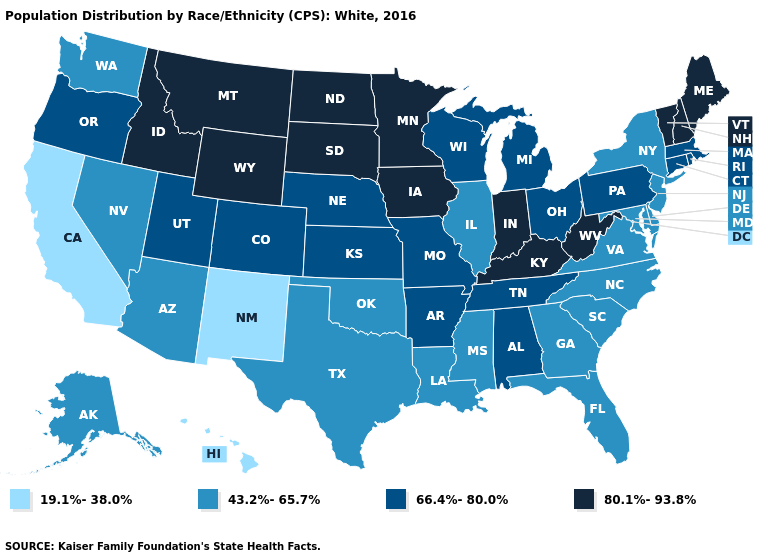What is the lowest value in the MidWest?
Be succinct. 43.2%-65.7%. Which states have the highest value in the USA?
Short answer required. Idaho, Indiana, Iowa, Kentucky, Maine, Minnesota, Montana, New Hampshire, North Dakota, South Dakota, Vermont, West Virginia, Wyoming. Name the states that have a value in the range 66.4%-80.0%?
Quick response, please. Alabama, Arkansas, Colorado, Connecticut, Kansas, Massachusetts, Michigan, Missouri, Nebraska, Ohio, Oregon, Pennsylvania, Rhode Island, Tennessee, Utah, Wisconsin. What is the value of Tennessee?
Write a very short answer. 66.4%-80.0%. Name the states that have a value in the range 80.1%-93.8%?
Keep it brief. Idaho, Indiana, Iowa, Kentucky, Maine, Minnesota, Montana, New Hampshire, North Dakota, South Dakota, Vermont, West Virginia, Wyoming. Does Georgia have a higher value than Hawaii?
Short answer required. Yes. Which states hav the highest value in the West?
Be succinct. Idaho, Montana, Wyoming. Among the states that border Massachusetts , does Rhode Island have the lowest value?
Keep it brief. No. How many symbols are there in the legend?
Answer briefly. 4. What is the lowest value in the South?
Give a very brief answer. 43.2%-65.7%. What is the value of New Hampshire?
Keep it brief. 80.1%-93.8%. Does the map have missing data?
Be succinct. No. Name the states that have a value in the range 19.1%-38.0%?
Be succinct. California, Hawaii, New Mexico. Does New Mexico have the lowest value in the West?
Write a very short answer. Yes. 